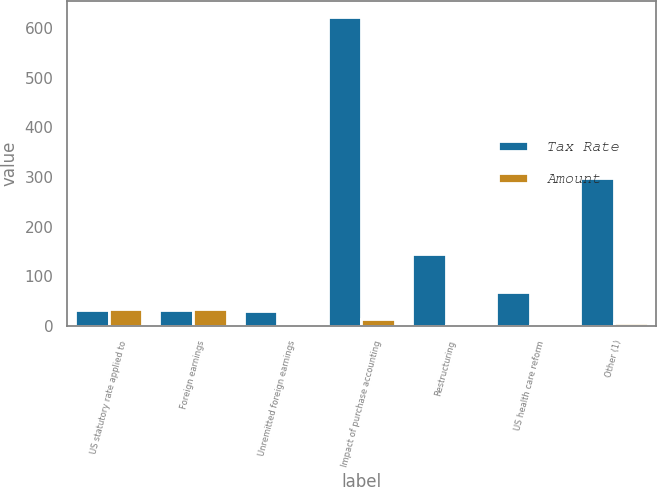Convert chart. <chart><loc_0><loc_0><loc_500><loc_500><stacked_bar_chart><ecel><fcel>US statutory rate applied to<fcel>Foreign earnings<fcel>Unremitted foreign earnings<fcel>Impact of purchase accounting<fcel>Restructuring<fcel>US health care reform<fcel>Other (1)<nl><fcel>Tax Rate<fcel>32.1<fcel>32.1<fcel>30<fcel>623<fcel>145<fcel>68<fcel>299<nl><fcel>Amount<fcel>35<fcel>34.2<fcel>0.6<fcel>13.4<fcel>3.1<fcel>1.4<fcel>6.4<nl></chart> 